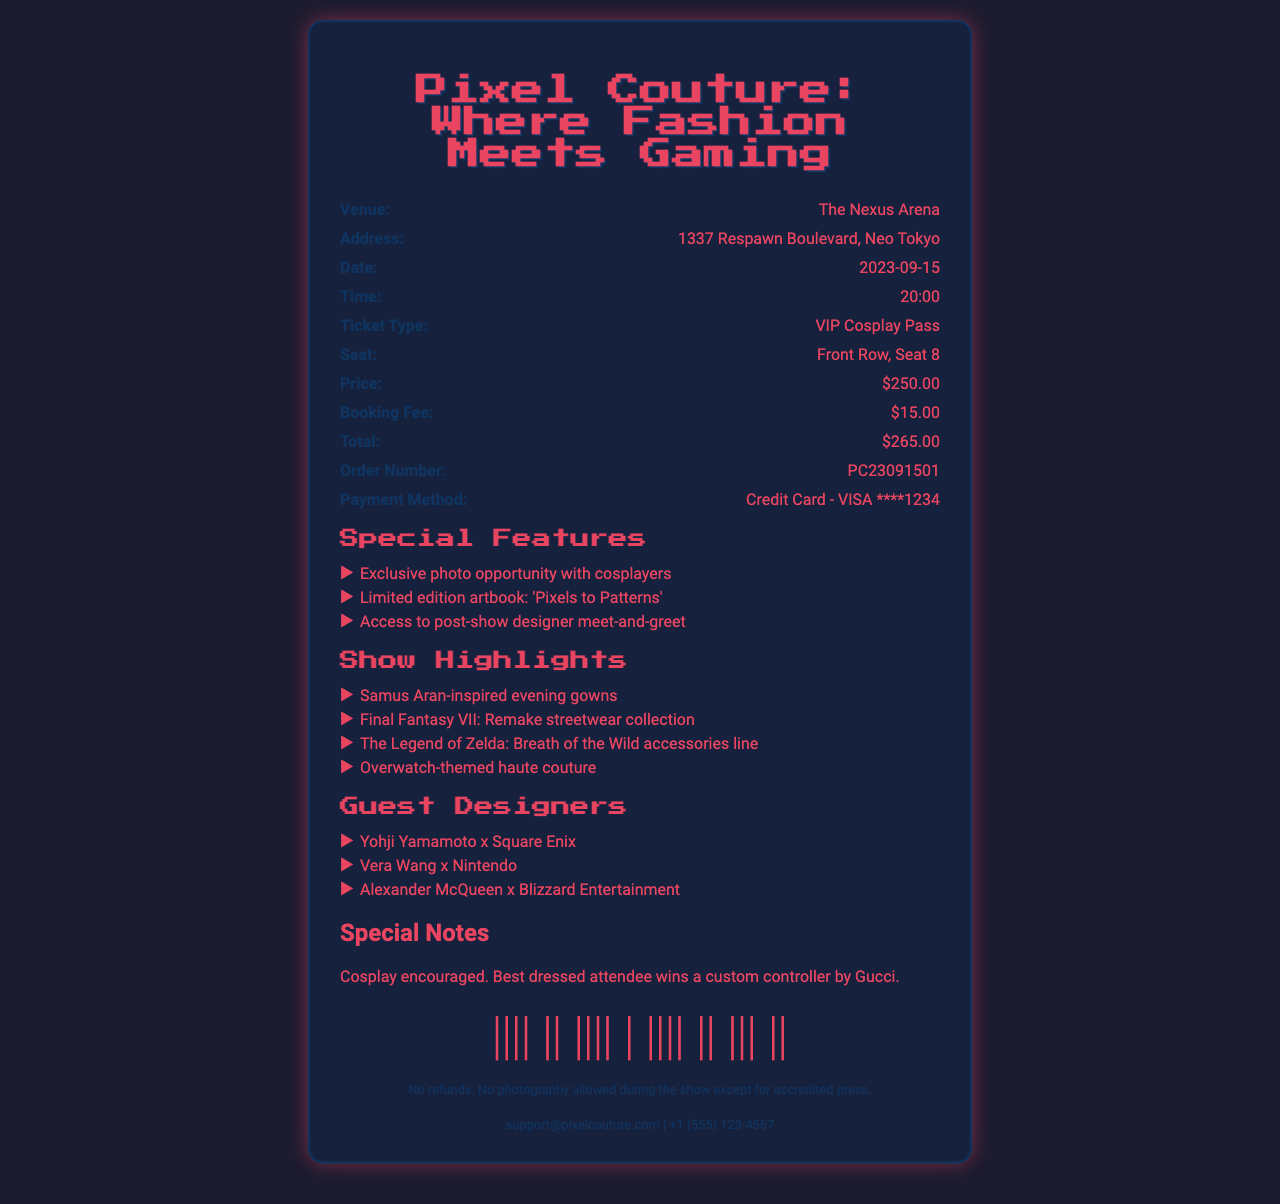what is the event name? The event name is specifically mentioned at the top of the receipt.
Answer: Pixel Couture: Where Fashion Meets Gaming where is the venue located? The venue address is detailed in the receipt, providing specific location information.
Answer: 1337 Respawn Boulevard, Neo Tokyo what date is the show? The date of the event is clearly specified in the document.
Answer: 2023-09-15 what is the total price for the ticket? The total price includes the ticket price and the booking fee, as indicated in the document.
Answer: $265.00 which ticket type is mentioned? The ticket type is explicitly stated in the receipt.
Answer: VIP Cosplay Pass who are the guest designers? The names of the guest designers are listed in a section of the document.
Answer: Yohji Yamamoto x Square Enix what special feature involves cosplayers? One of the special features includes an exclusive opportunity related to cosplayers.
Answer: Exclusive photo opportunity with cosplayers how many show highlights are there? The number of highlights is determined by counting the items listed in the document.
Answer: 4 what are the terms and conditions concerning refunds? The terms and conditions specify rules regarding refunds mentioned in the receipt.
Answer: No refunds 